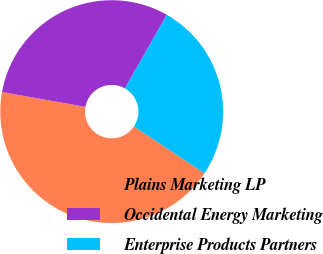Convert chart. <chart><loc_0><loc_0><loc_500><loc_500><pie_chart><fcel>Plains Marketing LP<fcel>Occidental Energy Marketing<fcel>Enterprise Products Partners<nl><fcel>43.48%<fcel>30.43%<fcel>26.09%<nl></chart> 